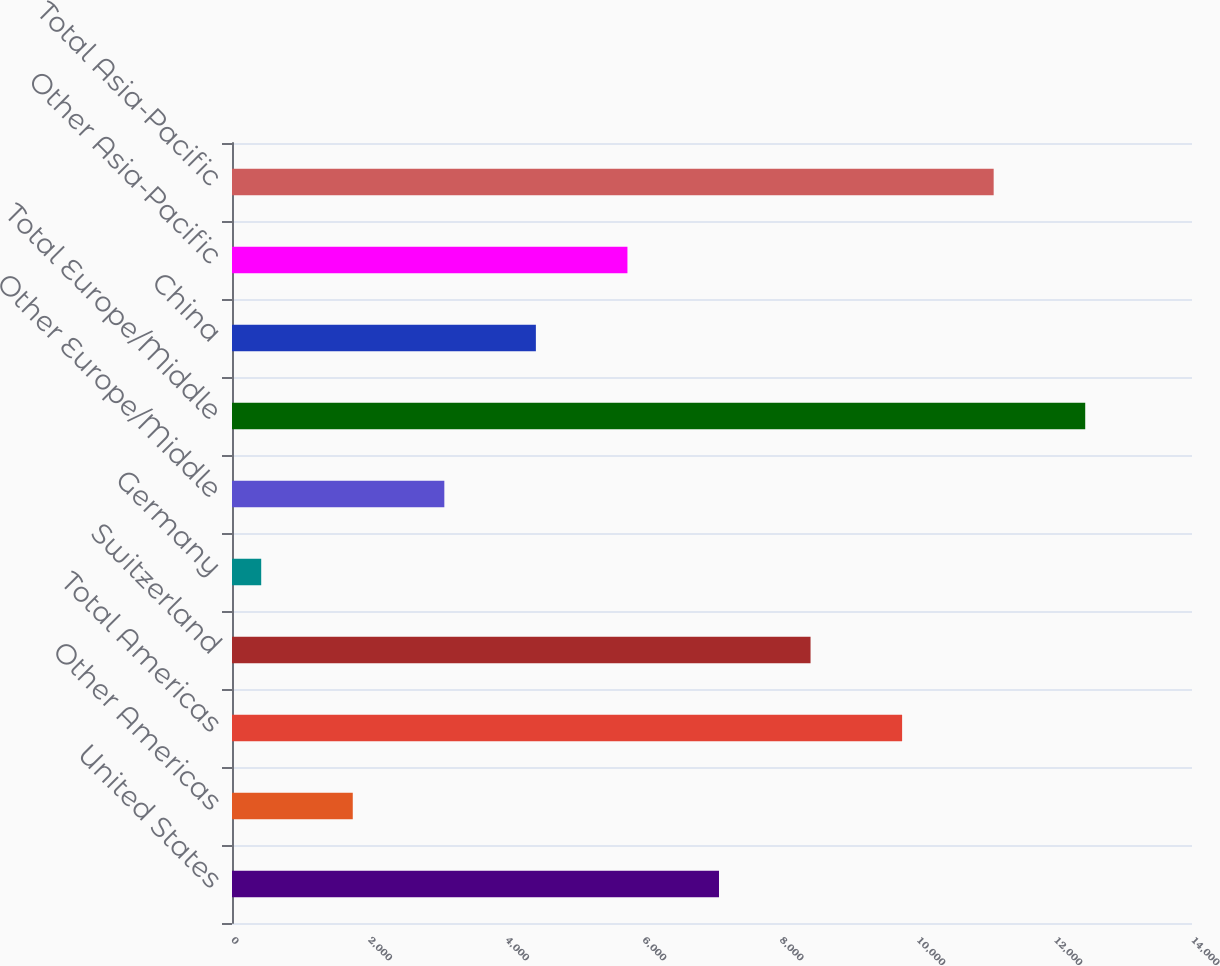Convert chart to OTSL. <chart><loc_0><loc_0><loc_500><loc_500><bar_chart><fcel>United States<fcel>Other Americas<fcel>Total Americas<fcel>Switzerland<fcel>Germany<fcel>Other Europe/Middle<fcel>Total Europe/Middle<fcel>China<fcel>Other Asia-Pacific<fcel>Total Asia-Pacific<nl><fcel>7102<fcel>1761.2<fcel>9772.4<fcel>8437.2<fcel>426<fcel>3096.4<fcel>12442.8<fcel>4431.6<fcel>5766.8<fcel>11107.6<nl></chart> 